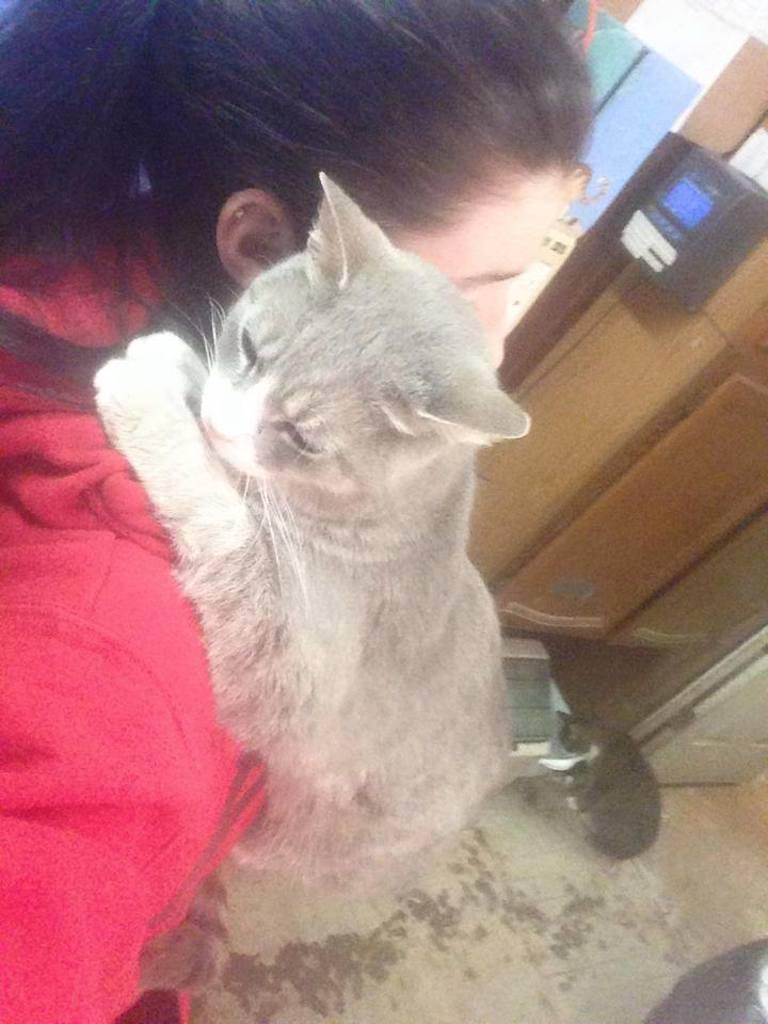Who is the main subject in the image? There is a girl in the image. What is the girl wearing? The girl is wearing a red sweater. What is the girl doing with the cat in the image? The girl is carrying a cat on her shoulder. Are there any other animals present in the image? Yes, there is another cat on the ground in the image. What type of vegetable is the girl holding in the image? There is no vegetable present in the image; the girl is carrying a cat on her shoulder. What is the girl's wish while holding the cat in the image? The image does not provide any information about the girl's wishes or thoughts, so we cannot answer this question. 